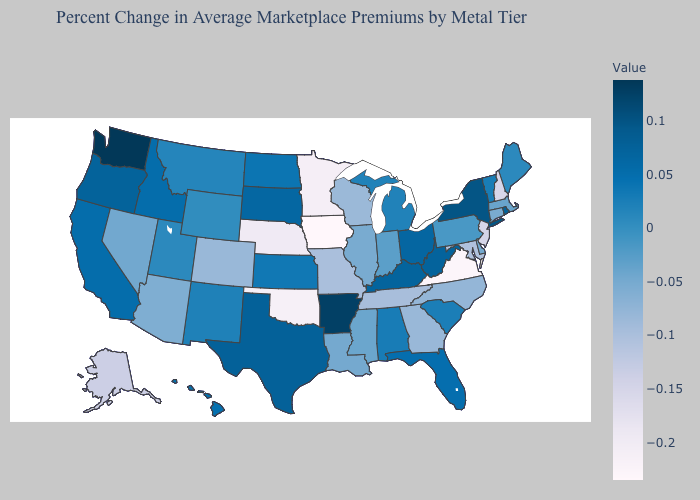Does Washington have the highest value in the USA?
Short answer required. Yes. Does Vermont have the highest value in the USA?
Quick response, please. No. Does Maryland have the highest value in the USA?
Short answer required. No. 